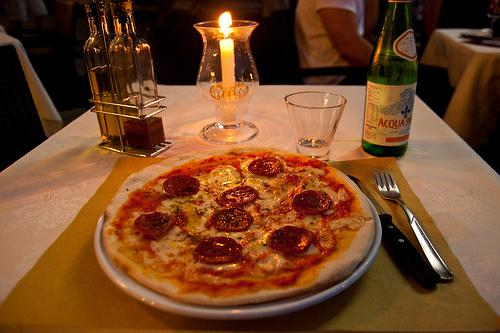Question: where is this pizza served?
Choices:
A. Baseball game.
B. Skating rink.
C. At a restaurant.
D. A party.
Answer with the letter. Answer: C Question: who is across from the table?
Choices:
A. A girl in blue.
B. A person in a white shirt.
C. A baby in a high chair.
D. A man smoking.
Answer with the letter. Answer: B Question: what food is being served?
Choices:
A. Pizza.
B. A cake.
C. A hamburger.
D. Sandwiches.
Answer with the letter. Answer: A Question: why is there a candle?
Choices:
A. To provide light.
B. To provide warmth.
C. To scent the room.
D. To create a nice ambiance.
Answer with the letter. Answer: D Question: what is in the cruet set?
Choices:
A. Lemon juice.
B. Oil and vinaigrette.
C. Flavored oils.
D. Herbal seasonings.
Answer with the letter. Answer: B Question: what utensils are there?
Choices:
A. Spoons.
B. Fork and knife.
C. Steak knives.
D. Serving tongs.
Answer with the letter. Answer: B 